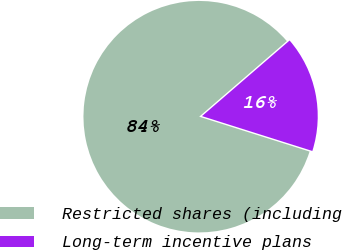Convert chart. <chart><loc_0><loc_0><loc_500><loc_500><pie_chart><fcel>Restricted shares (including<fcel>Long-term incentive plans<nl><fcel>83.8%<fcel>16.2%<nl></chart> 